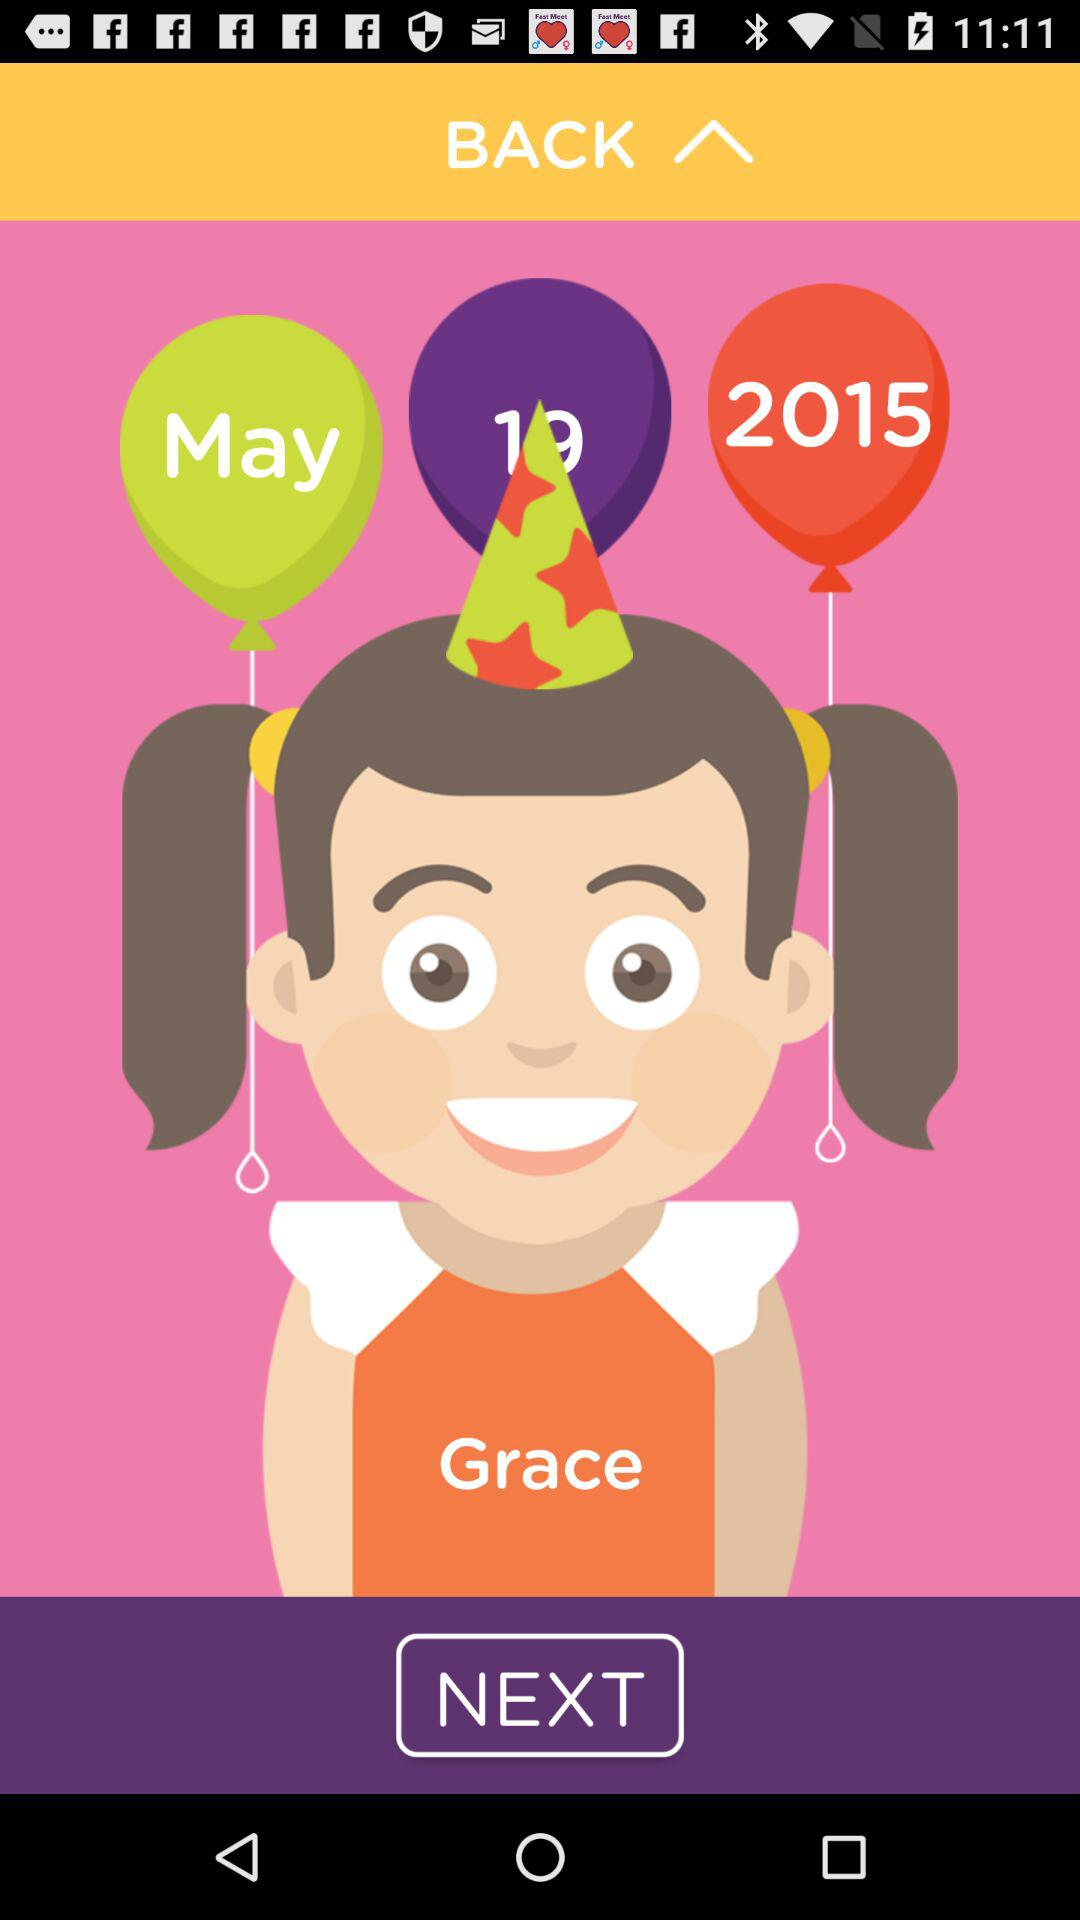What is the given date of birth? The given date of birth is May 19, 2015. 